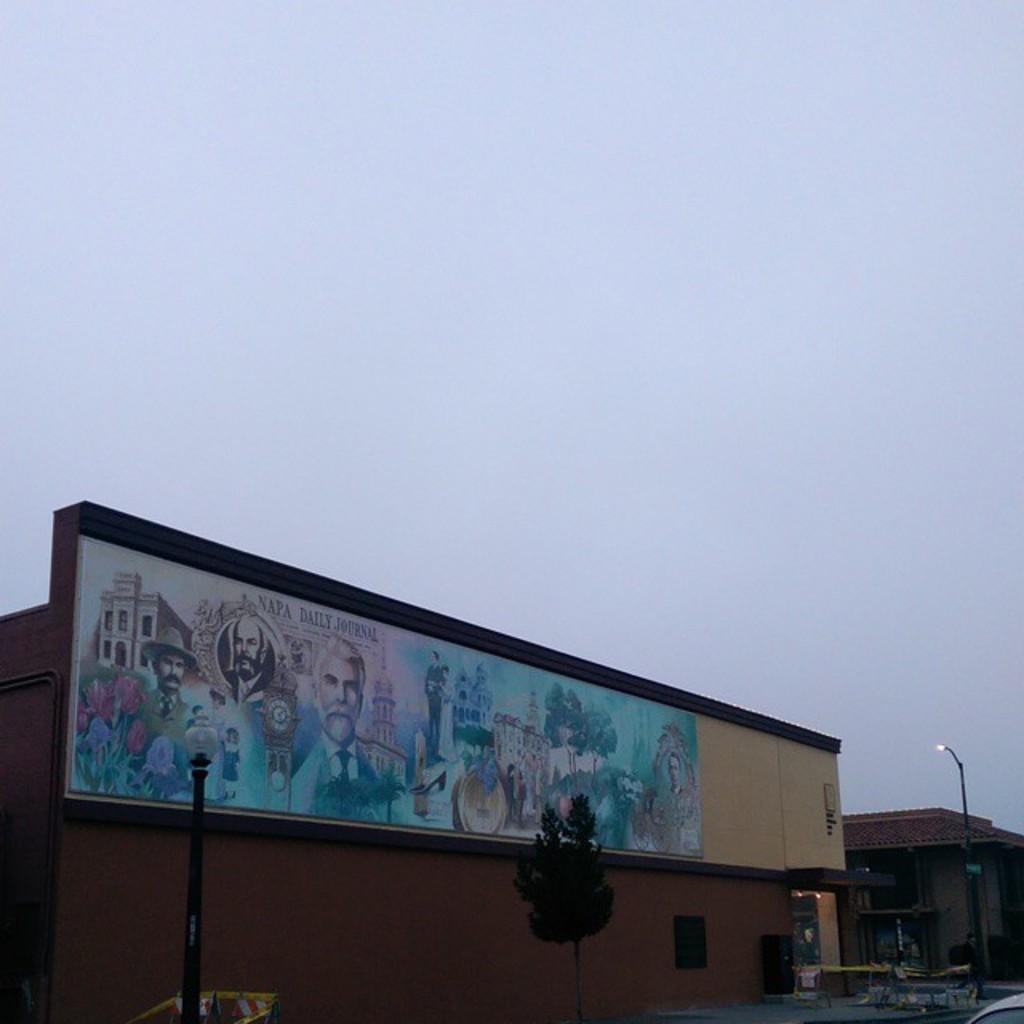What does napa daily mean above the white haired man mean?
Provide a succinct answer. Journal. 